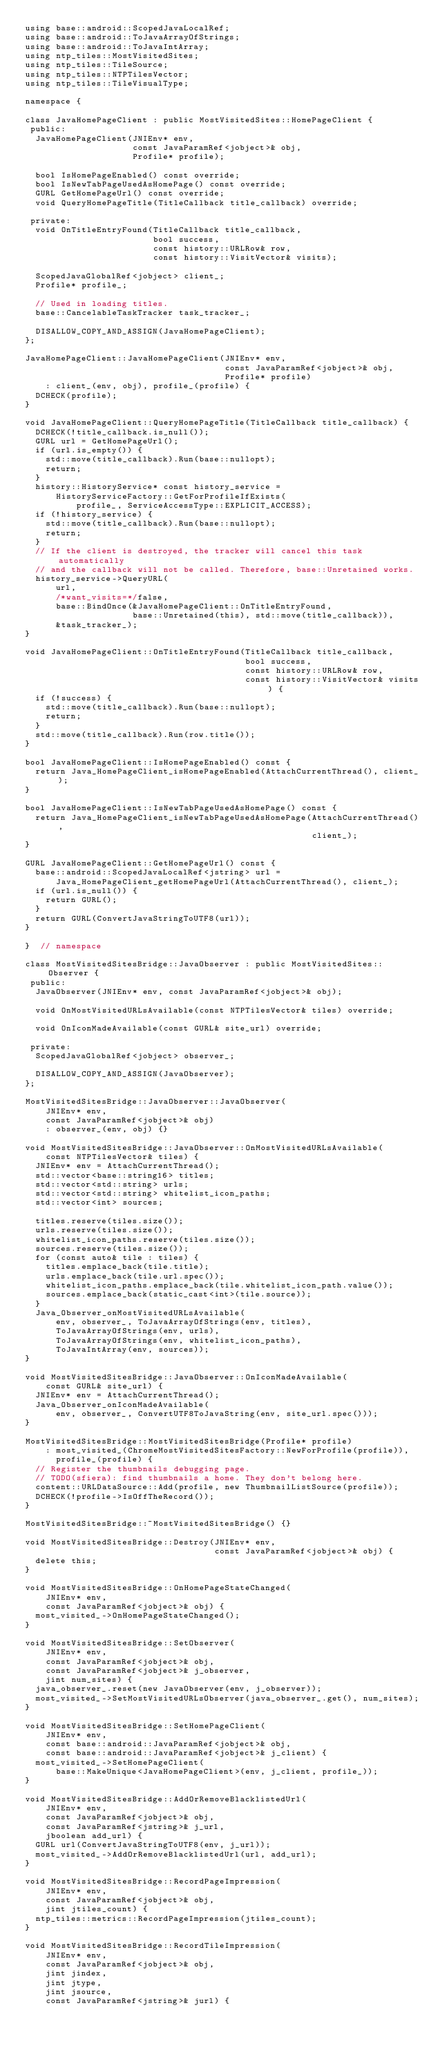<code> <loc_0><loc_0><loc_500><loc_500><_C++_>using base::android::ScopedJavaLocalRef;
using base::android::ToJavaArrayOfStrings;
using base::android::ToJavaIntArray;
using ntp_tiles::MostVisitedSites;
using ntp_tiles::TileSource;
using ntp_tiles::NTPTilesVector;
using ntp_tiles::TileVisualType;

namespace {

class JavaHomePageClient : public MostVisitedSites::HomePageClient {
 public:
  JavaHomePageClient(JNIEnv* env,
                     const JavaParamRef<jobject>& obj,
                     Profile* profile);

  bool IsHomePageEnabled() const override;
  bool IsNewTabPageUsedAsHomePage() const override;
  GURL GetHomePageUrl() const override;
  void QueryHomePageTitle(TitleCallback title_callback) override;

 private:
  void OnTitleEntryFound(TitleCallback title_callback,
                         bool success,
                         const history::URLRow& row,
                         const history::VisitVector& visits);

  ScopedJavaGlobalRef<jobject> client_;
  Profile* profile_;

  // Used in loading titles.
  base::CancelableTaskTracker task_tracker_;

  DISALLOW_COPY_AND_ASSIGN(JavaHomePageClient);
};

JavaHomePageClient::JavaHomePageClient(JNIEnv* env,
                                       const JavaParamRef<jobject>& obj,
                                       Profile* profile)
    : client_(env, obj), profile_(profile) {
  DCHECK(profile);
}

void JavaHomePageClient::QueryHomePageTitle(TitleCallback title_callback) {
  DCHECK(!title_callback.is_null());
  GURL url = GetHomePageUrl();
  if (url.is_empty()) {
    std::move(title_callback).Run(base::nullopt);
    return;
  }
  history::HistoryService* const history_service =
      HistoryServiceFactory::GetForProfileIfExists(
          profile_, ServiceAccessType::EXPLICIT_ACCESS);
  if (!history_service) {
    std::move(title_callback).Run(base::nullopt);
    return;
  }
  // If the client is destroyed, the tracker will cancel this task automatically
  // and the callback will not be called. Therefore, base::Unretained works.
  history_service->QueryURL(
      url,
      /*want_visits=*/false,
      base::BindOnce(&JavaHomePageClient::OnTitleEntryFound,
                     base::Unretained(this), std::move(title_callback)),
      &task_tracker_);
}

void JavaHomePageClient::OnTitleEntryFound(TitleCallback title_callback,
                                           bool success,
                                           const history::URLRow& row,
                                           const history::VisitVector& visits) {
  if (!success) {
    std::move(title_callback).Run(base::nullopt);
    return;
  }
  std::move(title_callback).Run(row.title());
}

bool JavaHomePageClient::IsHomePageEnabled() const {
  return Java_HomePageClient_isHomePageEnabled(AttachCurrentThread(), client_);
}

bool JavaHomePageClient::IsNewTabPageUsedAsHomePage() const {
  return Java_HomePageClient_isNewTabPageUsedAsHomePage(AttachCurrentThread(),
                                                        client_);
}

GURL JavaHomePageClient::GetHomePageUrl() const {
  base::android::ScopedJavaLocalRef<jstring> url =
      Java_HomePageClient_getHomePageUrl(AttachCurrentThread(), client_);
  if (url.is_null()) {
    return GURL();
  }
  return GURL(ConvertJavaStringToUTF8(url));
}

}  // namespace

class MostVisitedSitesBridge::JavaObserver : public MostVisitedSites::Observer {
 public:
  JavaObserver(JNIEnv* env, const JavaParamRef<jobject>& obj);

  void OnMostVisitedURLsAvailable(const NTPTilesVector& tiles) override;

  void OnIconMadeAvailable(const GURL& site_url) override;

 private:
  ScopedJavaGlobalRef<jobject> observer_;

  DISALLOW_COPY_AND_ASSIGN(JavaObserver);
};

MostVisitedSitesBridge::JavaObserver::JavaObserver(
    JNIEnv* env,
    const JavaParamRef<jobject>& obj)
    : observer_(env, obj) {}

void MostVisitedSitesBridge::JavaObserver::OnMostVisitedURLsAvailable(
    const NTPTilesVector& tiles) {
  JNIEnv* env = AttachCurrentThread();
  std::vector<base::string16> titles;
  std::vector<std::string> urls;
  std::vector<std::string> whitelist_icon_paths;
  std::vector<int> sources;

  titles.reserve(tiles.size());
  urls.reserve(tiles.size());
  whitelist_icon_paths.reserve(tiles.size());
  sources.reserve(tiles.size());
  for (const auto& tile : tiles) {
    titles.emplace_back(tile.title);
    urls.emplace_back(tile.url.spec());
    whitelist_icon_paths.emplace_back(tile.whitelist_icon_path.value());
    sources.emplace_back(static_cast<int>(tile.source));
  }
  Java_Observer_onMostVisitedURLsAvailable(
      env, observer_, ToJavaArrayOfStrings(env, titles),
      ToJavaArrayOfStrings(env, urls),
      ToJavaArrayOfStrings(env, whitelist_icon_paths),
      ToJavaIntArray(env, sources));
}

void MostVisitedSitesBridge::JavaObserver::OnIconMadeAvailable(
    const GURL& site_url) {
  JNIEnv* env = AttachCurrentThread();
  Java_Observer_onIconMadeAvailable(
      env, observer_, ConvertUTF8ToJavaString(env, site_url.spec()));
}

MostVisitedSitesBridge::MostVisitedSitesBridge(Profile* profile)
    : most_visited_(ChromeMostVisitedSitesFactory::NewForProfile(profile)),
      profile_(profile) {
  // Register the thumbnails debugging page.
  // TODO(sfiera): find thumbnails a home. They don't belong here.
  content::URLDataSource::Add(profile, new ThumbnailListSource(profile));
  DCHECK(!profile->IsOffTheRecord());
}

MostVisitedSitesBridge::~MostVisitedSitesBridge() {}

void MostVisitedSitesBridge::Destroy(JNIEnv* env,
                                     const JavaParamRef<jobject>& obj) {
  delete this;
}

void MostVisitedSitesBridge::OnHomePageStateChanged(
    JNIEnv* env,
    const JavaParamRef<jobject>& obj) {
  most_visited_->OnHomePageStateChanged();
}

void MostVisitedSitesBridge::SetObserver(
    JNIEnv* env,
    const JavaParamRef<jobject>& obj,
    const JavaParamRef<jobject>& j_observer,
    jint num_sites) {
  java_observer_.reset(new JavaObserver(env, j_observer));
  most_visited_->SetMostVisitedURLsObserver(java_observer_.get(), num_sites);
}

void MostVisitedSitesBridge::SetHomePageClient(
    JNIEnv* env,
    const base::android::JavaParamRef<jobject>& obj,
    const base::android::JavaParamRef<jobject>& j_client) {
  most_visited_->SetHomePageClient(
      base::MakeUnique<JavaHomePageClient>(env, j_client, profile_));
}

void MostVisitedSitesBridge::AddOrRemoveBlacklistedUrl(
    JNIEnv* env,
    const JavaParamRef<jobject>& obj,
    const JavaParamRef<jstring>& j_url,
    jboolean add_url) {
  GURL url(ConvertJavaStringToUTF8(env, j_url));
  most_visited_->AddOrRemoveBlacklistedUrl(url, add_url);
}

void MostVisitedSitesBridge::RecordPageImpression(
    JNIEnv* env,
    const JavaParamRef<jobject>& obj,
    jint jtiles_count) {
  ntp_tiles::metrics::RecordPageImpression(jtiles_count);
}

void MostVisitedSitesBridge::RecordTileImpression(
    JNIEnv* env,
    const JavaParamRef<jobject>& obj,
    jint jindex,
    jint jtype,
    jint jsource,
    const JavaParamRef<jstring>& jurl) {</code> 